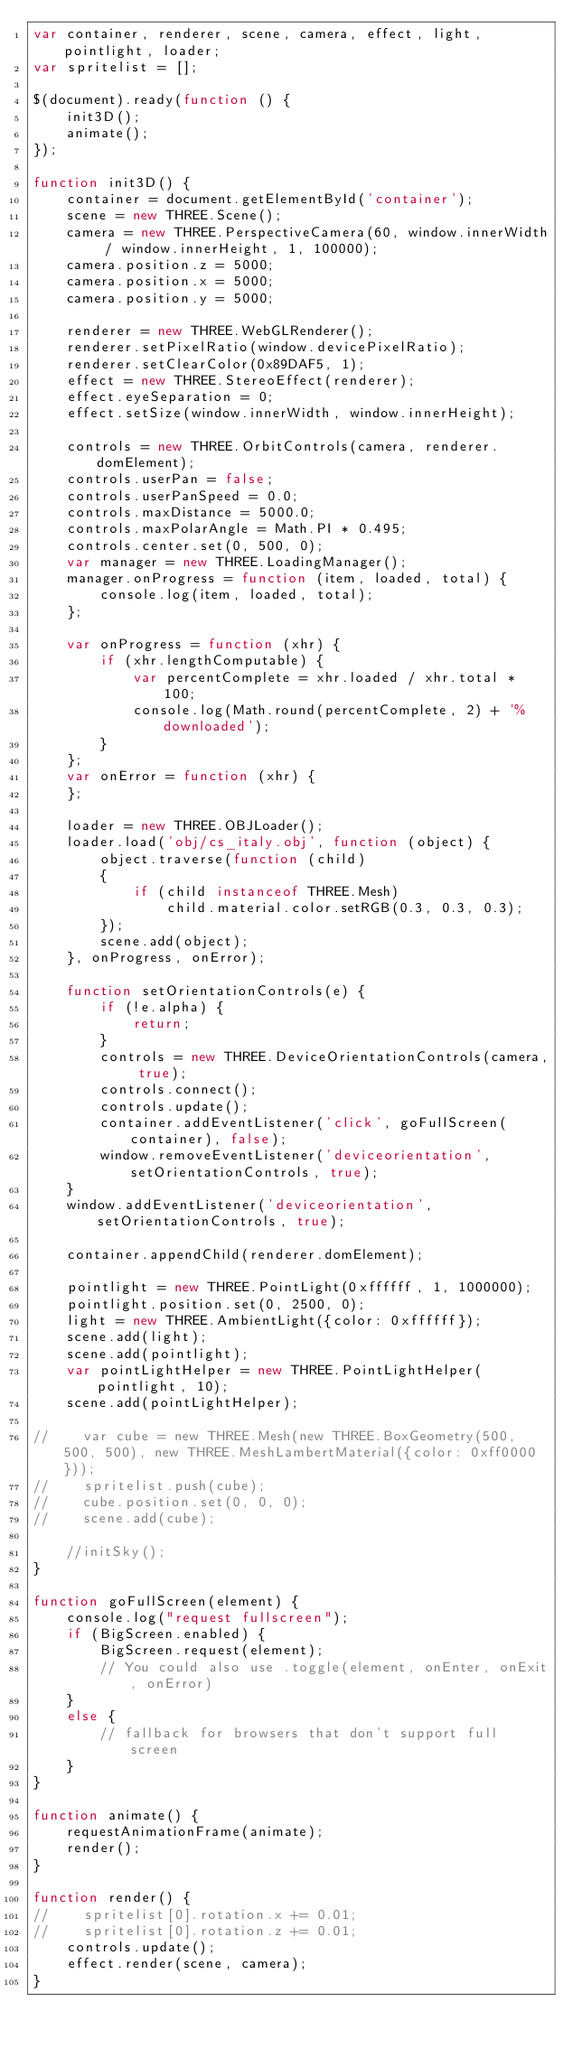<code> <loc_0><loc_0><loc_500><loc_500><_JavaScript_>var container, renderer, scene, camera, effect, light, pointlight, loader;
var spritelist = [];

$(document).ready(function () {
    init3D();
    animate();
});

function init3D() {
    container = document.getElementById('container');
    scene = new THREE.Scene();
    camera = new THREE.PerspectiveCamera(60, window.innerWidth / window.innerHeight, 1, 100000);
    camera.position.z = 5000;
    camera.position.x = 5000;
    camera.position.y = 5000;

    renderer = new THREE.WebGLRenderer();
    renderer.setPixelRatio(window.devicePixelRatio);
    renderer.setClearColor(0x89DAF5, 1);
    effect = new THREE.StereoEffect(renderer);
    effect.eyeSeparation = 0;
    effect.setSize(window.innerWidth, window.innerHeight);

    controls = new THREE.OrbitControls(camera, renderer.domElement);
    controls.userPan = false;
    controls.userPanSpeed = 0.0;
    controls.maxDistance = 5000.0;
    controls.maxPolarAngle = Math.PI * 0.495;
    controls.center.set(0, 500, 0);
    var manager = new THREE.LoadingManager();
    manager.onProgress = function (item, loaded, total) {
        console.log(item, loaded, total);
    };

    var onProgress = function (xhr) {
        if (xhr.lengthComputable) {
            var percentComplete = xhr.loaded / xhr.total * 100;
            console.log(Math.round(percentComplete, 2) + '% downloaded');
        }
    };
    var onError = function (xhr) {
    };

    loader = new THREE.OBJLoader();
    loader.load('obj/cs_italy.obj', function (object) {
        object.traverse(function (child)
        {
            if (child instanceof THREE.Mesh)
                child.material.color.setRGB(0.3, 0.3, 0.3);
        });
        scene.add(object);
    }, onProgress, onError);

    function setOrientationControls(e) {
        if (!e.alpha) {
            return;
        }
        controls = new THREE.DeviceOrientationControls(camera, true);
        controls.connect();
        controls.update();
        container.addEventListener('click', goFullScreen(container), false);
        window.removeEventListener('deviceorientation', setOrientationControls, true);
    }
    window.addEventListener('deviceorientation', setOrientationControls, true);

    container.appendChild(renderer.domElement);

    pointlight = new THREE.PointLight(0xffffff, 1, 1000000);
    pointlight.position.set(0, 2500, 0);
    light = new THREE.AmbientLight({color: 0xffffff});
    scene.add(light);
    scene.add(pointlight);
    var pointLightHelper = new THREE.PointLightHelper(pointlight, 10);
    scene.add(pointLightHelper);

//    var cube = new THREE.Mesh(new THREE.BoxGeometry(500, 500, 500), new THREE.MeshLambertMaterial({color: 0xff0000}));
//    spritelist.push(cube);
//    cube.position.set(0, 0, 0);
//    scene.add(cube);

    //initSky();
}

function goFullScreen(element) {
    console.log("request fullscreen");
    if (BigScreen.enabled) {
        BigScreen.request(element);
        // You could also use .toggle(element, onEnter, onExit, onError)
    }
    else {
        // fallback for browsers that don't support full screen
    }
}

function animate() {
    requestAnimationFrame(animate);
    render();
}

function render() {
//    spritelist[0].rotation.x += 0.01;
//    spritelist[0].rotation.z += 0.01;
    controls.update();
    effect.render(scene, camera);
}
</code> 